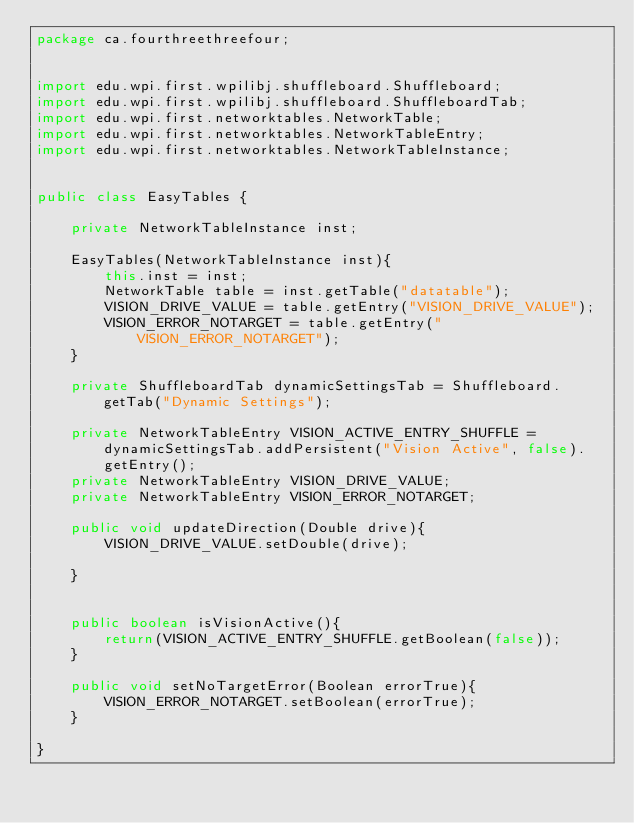Convert code to text. <code><loc_0><loc_0><loc_500><loc_500><_Java_>package ca.fourthreethreefour;


import edu.wpi.first.wpilibj.shuffleboard.Shuffleboard;
import edu.wpi.first.wpilibj.shuffleboard.ShuffleboardTab;
import edu.wpi.first.networktables.NetworkTable;
import edu.wpi.first.networktables.NetworkTableEntry;
import edu.wpi.first.networktables.NetworkTableInstance;


public class EasyTables {

    private NetworkTableInstance inst;

    EasyTables(NetworkTableInstance inst){
        this.inst = inst;
        NetworkTable table = inst.getTable("datatable");
        VISION_DRIVE_VALUE = table.getEntry("VISION_DRIVE_VALUE");
        VISION_ERROR_NOTARGET = table.getEntry("VISION_ERROR_NOTARGET");
    }

    private ShuffleboardTab dynamicSettingsTab = Shuffleboard.getTab("Dynamic Settings");
  
    private NetworkTableEntry VISION_ACTIVE_ENTRY_SHUFFLE = dynamicSettingsTab.addPersistent("Vision Active", false).getEntry();
    private NetworkTableEntry VISION_DRIVE_VALUE;
    private NetworkTableEntry VISION_ERROR_NOTARGET;

    public void updateDirection(Double drive){
        VISION_DRIVE_VALUE.setDouble(drive);
 
    }


    public boolean isVisionActive(){
        return(VISION_ACTIVE_ENTRY_SHUFFLE.getBoolean(false));
    }

    public void setNoTargetError(Boolean errorTrue){
        VISION_ERROR_NOTARGET.setBoolean(errorTrue);
    }
    
}</code> 